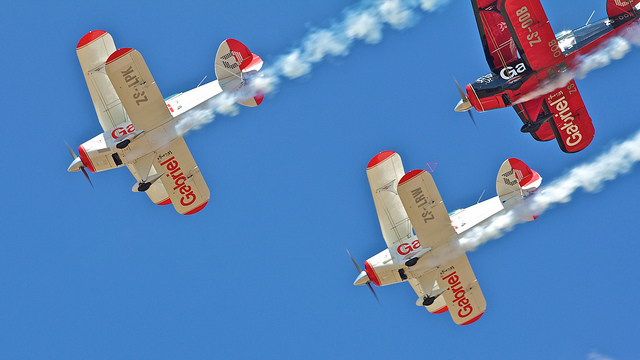Please identify all text content in this image. Gabriel Gabriel Gabriel LPK LRW 800 SZ 800 Ga Ga Ga 